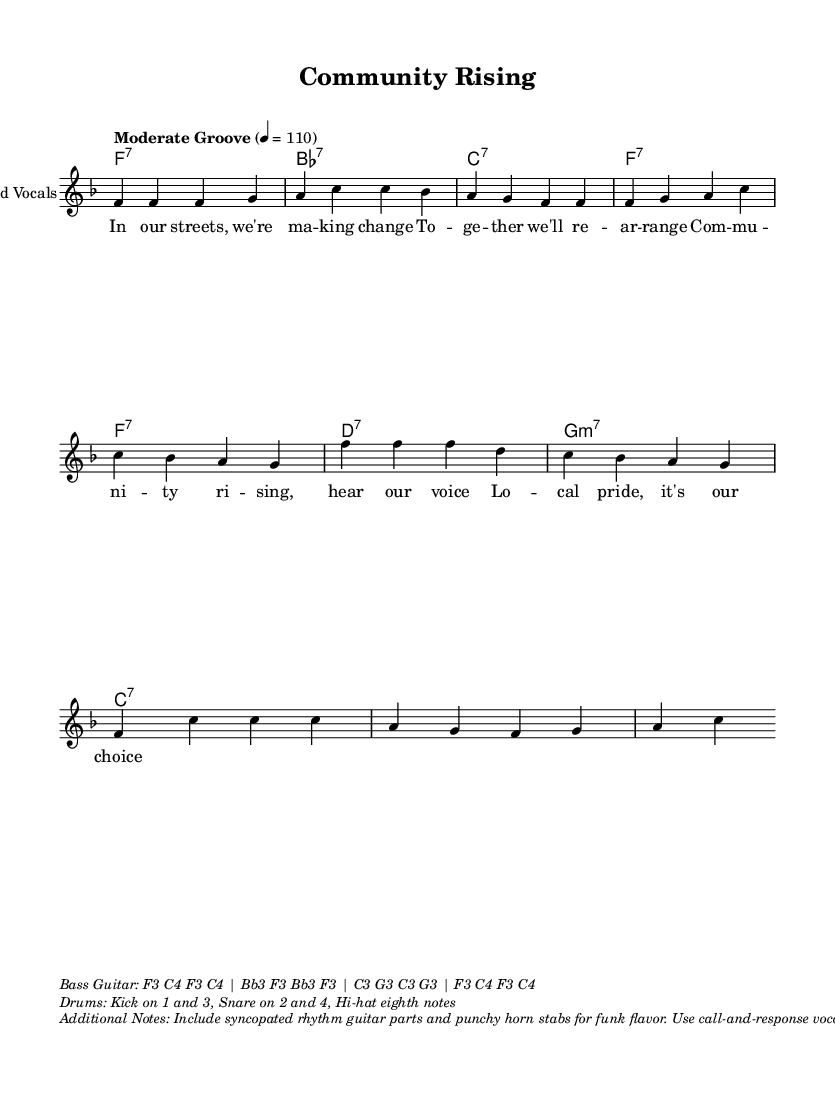What is the key signature of this music? The key signature shows one flat, indicating it is in F major.
Answer: F major What is the time signature of the music? The time signature is indicated at the beginning of the score, showing four beats in each measure.
Answer: 4/4 What is the tempo marking for this piece? The tempo marking at the beginning states to play at a moderate groove, with a metronome marking of 110 beats per minute.
Answer: Moderate Groove, 110 How many measures are in the melody line? By counting the measures in the melody, you can see a total of eight measures present in the provided music.
Answer: 8 What instrument is indicated for the lead vocals? In the score, the instrument name at the start specifies that the lead part is designated for vocals.
Answer: Lead Vocals What kind of rhythm section is suggested in the music? The additional notes indicate using specific drum patterns and bass rhythms, suggesting a funky style appropriate for the genre.
Answer: Funk rhythm What lyrical theme is presented in this piece? The lyrics reflect themes of community, local pride, and activism, emphasizing togetherness and change.
Answer: Community and activism 